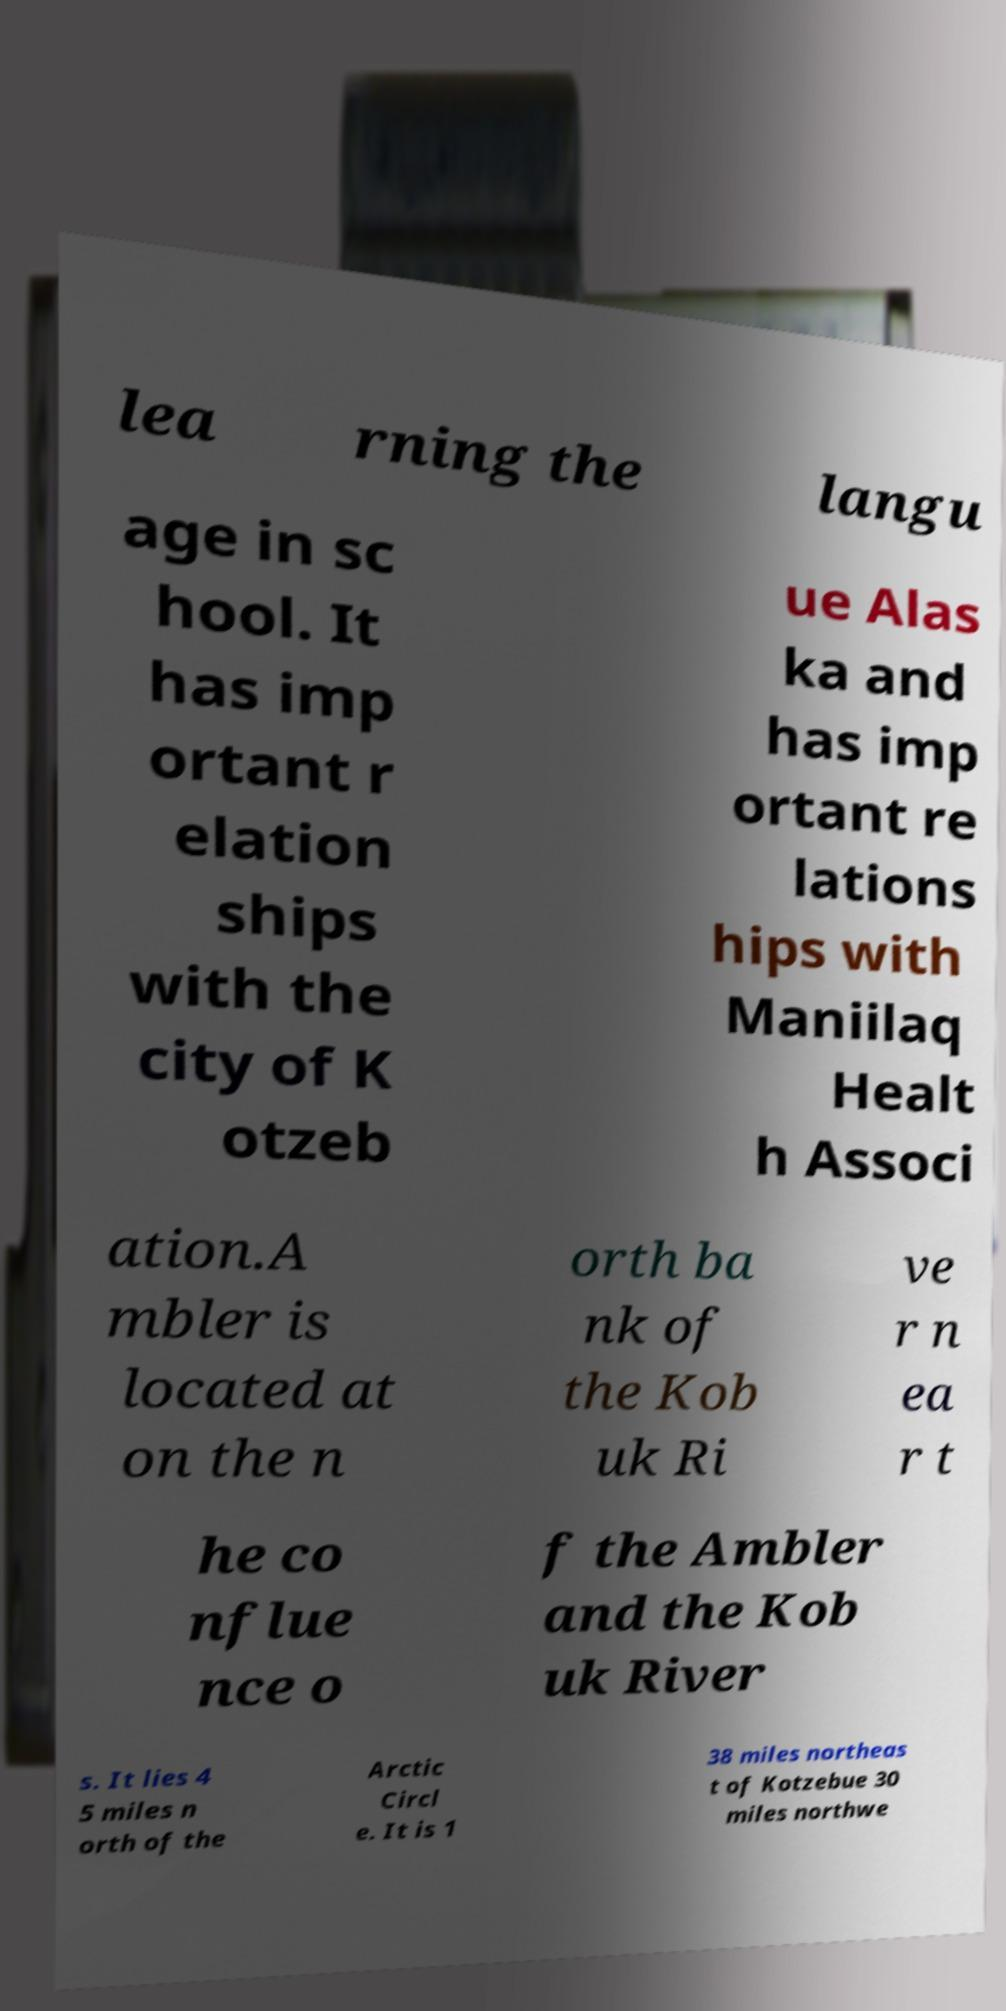What messages or text are displayed in this image? I need them in a readable, typed format. lea rning the langu age in sc hool. It has imp ortant r elation ships with the city of K otzeb ue Alas ka and has imp ortant re lations hips with Maniilaq Healt h Associ ation.A mbler is located at on the n orth ba nk of the Kob uk Ri ve r n ea r t he co nflue nce o f the Ambler and the Kob uk River s. It lies 4 5 miles n orth of the Arctic Circl e. It is 1 38 miles northeas t of Kotzebue 30 miles northwe 